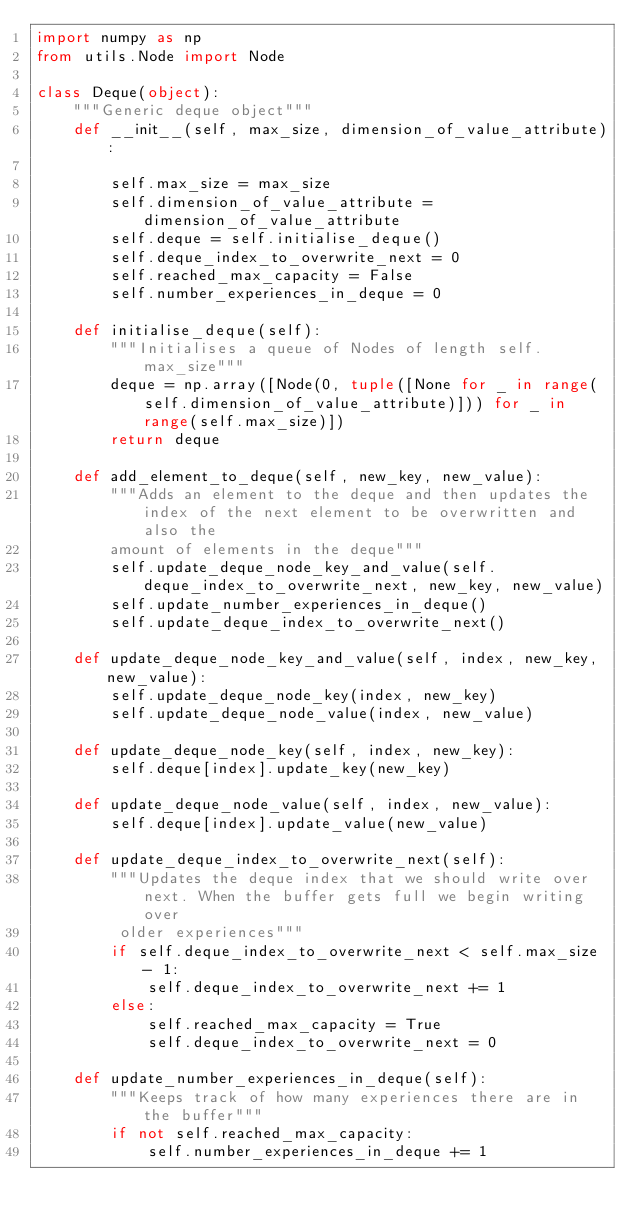<code> <loc_0><loc_0><loc_500><loc_500><_Python_>import numpy as np
from utils.Node import Node

class Deque(object):
    """Generic deque object"""
    def __init__(self, max_size, dimension_of_value_attribute):

        self.max_size = max_size
        self.dimension_of_value_attribute = dimension_of_value_attribute
        self.deque = self.initialise_deque()
        self.deque_index_to_overwrite_next = 0
        self.reached_max_capacity = False
        self.number_experiences_in_deque = 0

    def initialise_deque(self):
        """Initialises a queue of Nodes of length self.max_size"""
        deque = np.array([Node(0, tuple([None for _ in range(self.dimension_of_value_attribute)])) for _ in range(self.max_size)])
        return deque

    def add_element_to_deque(self, new_key, new_value):
        """Adds an element to the deque and then updates the index of the next element to be overwritten and also the
        amount of elements in the deque"""
        self.update_deque_node_key_and_value(self.deque_index_to_overwrite_next, new_key, new_value)
        self.update_number_experiences_in_deque()
        self.update_deque_index_to_overwrite_next()

    def update_deque_node_key_and_value(self, index, new_key, new_value):
        self.update_deque_node_key(index, new_key)
        self.update_deque_node_value(index, new_value)

    def update_deque_node_key(self, index, new_key):
        self.deque[index].update_key(new_key)

    def update_deque_node_value(self, index, new_value):
        self.deque[index].update_value(new_value)

    def update_deque_index_to_overwrite_next(self):
        """Updates the deque index that we should write over next. When the buffer gets full we begin writing over
         older experiences"""
        if self.deque_index_to_overwrite_next < self.max_size - 1:
            self.deque_index_to_overwrite_next += 1
        else:
            self.reached_max_capacity = True
            self.deque_index_to_overwrite_next = 0

    def update_number_experiences_in_deque(self):
        """Keeps track of how many experiences there are in the buffer"""
        if not self.reached_max_capacity:
            self.number_experiences_in_deque += 1</code> 